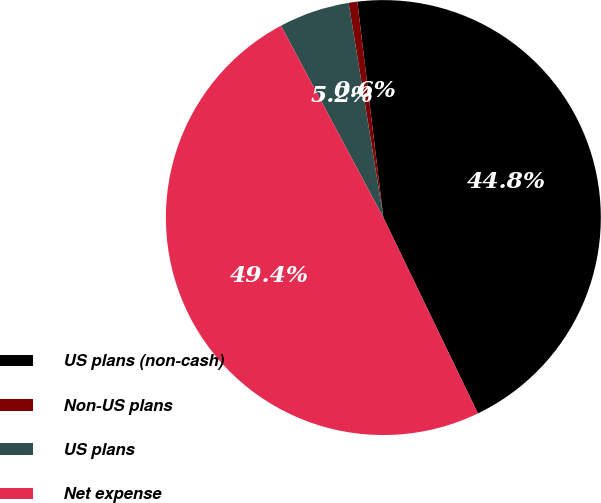Convert chart to OTSL. <chart><loc_0><loc_0><loc_500><loc_500><pie_chart><fcel>US plans (non-cash)<fcel>Non-US plans<fcel>US plans<fcel>Net expense<nl><fcel>44.75%<fcel>0.64%<fcel>5.25%<fcel>49.36%<nl></chart> 